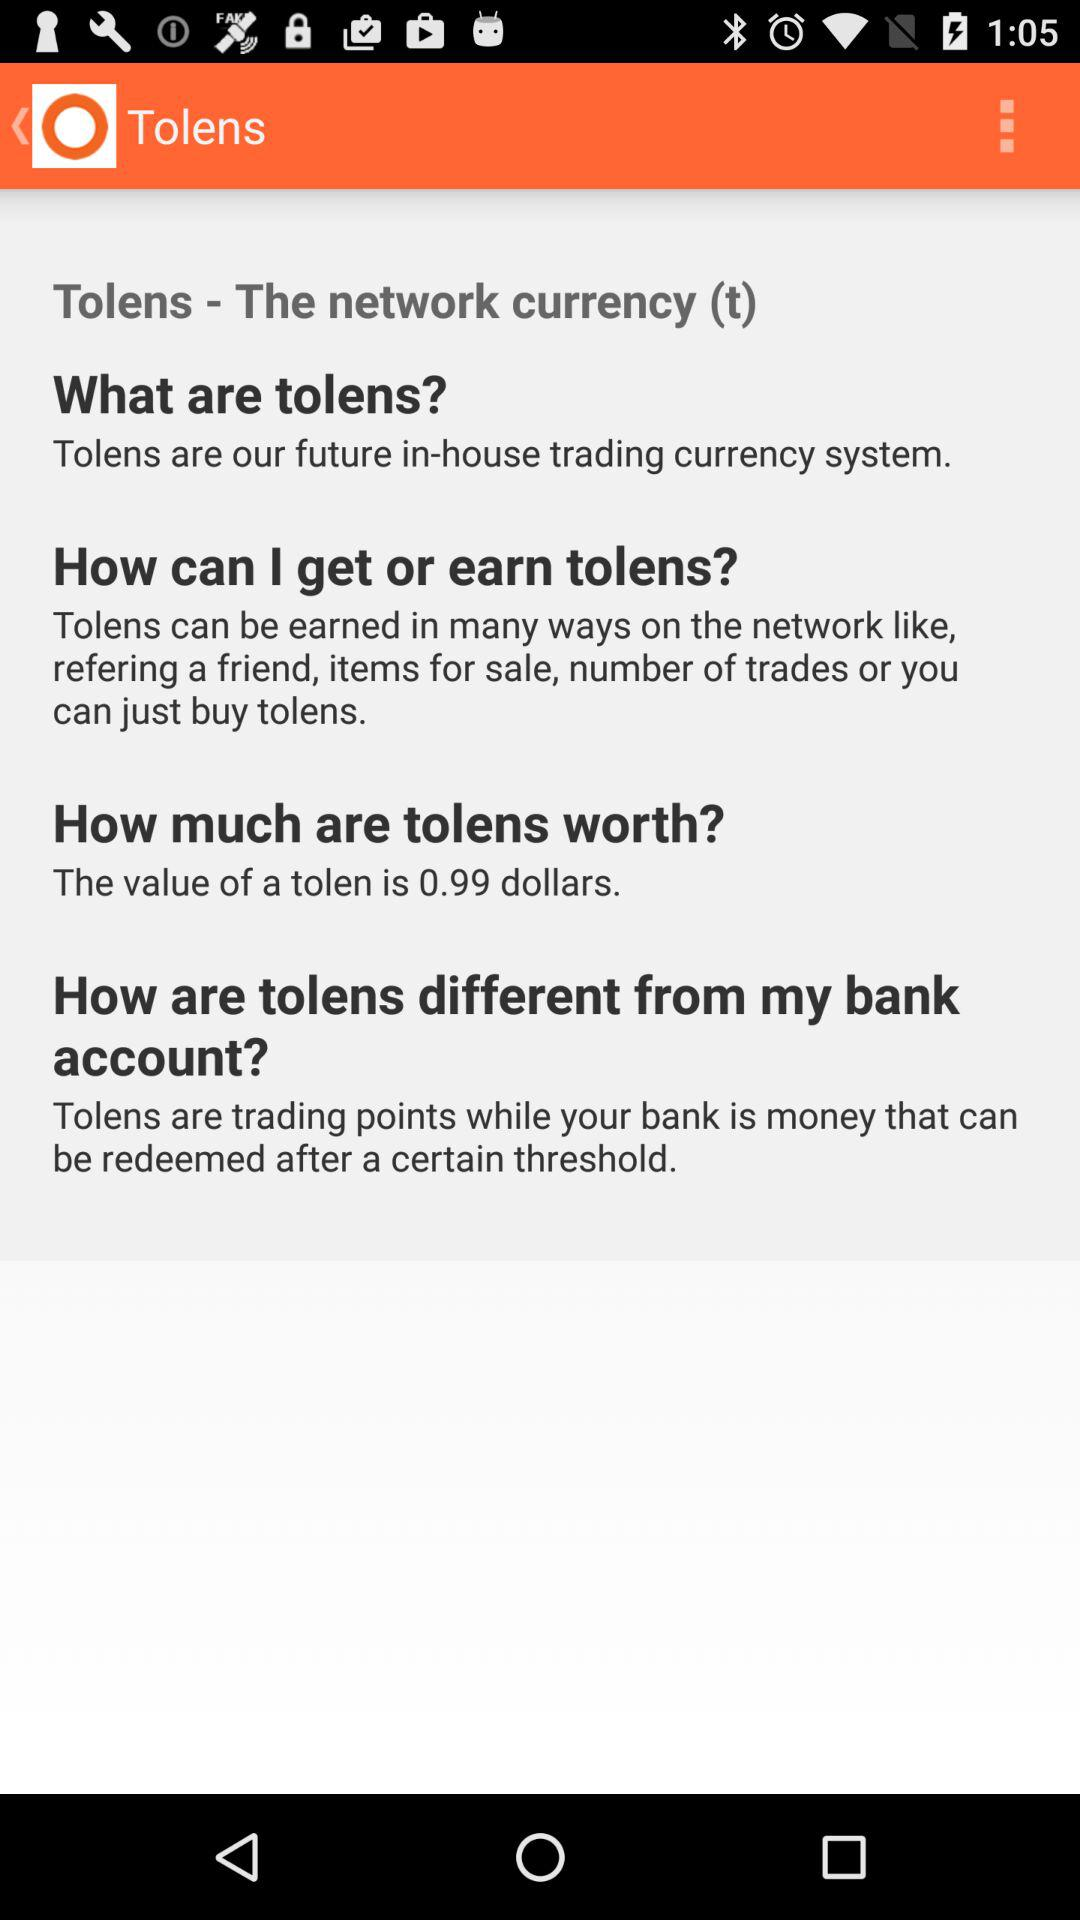What is the name of the application? The name of the application is "Tolens". 